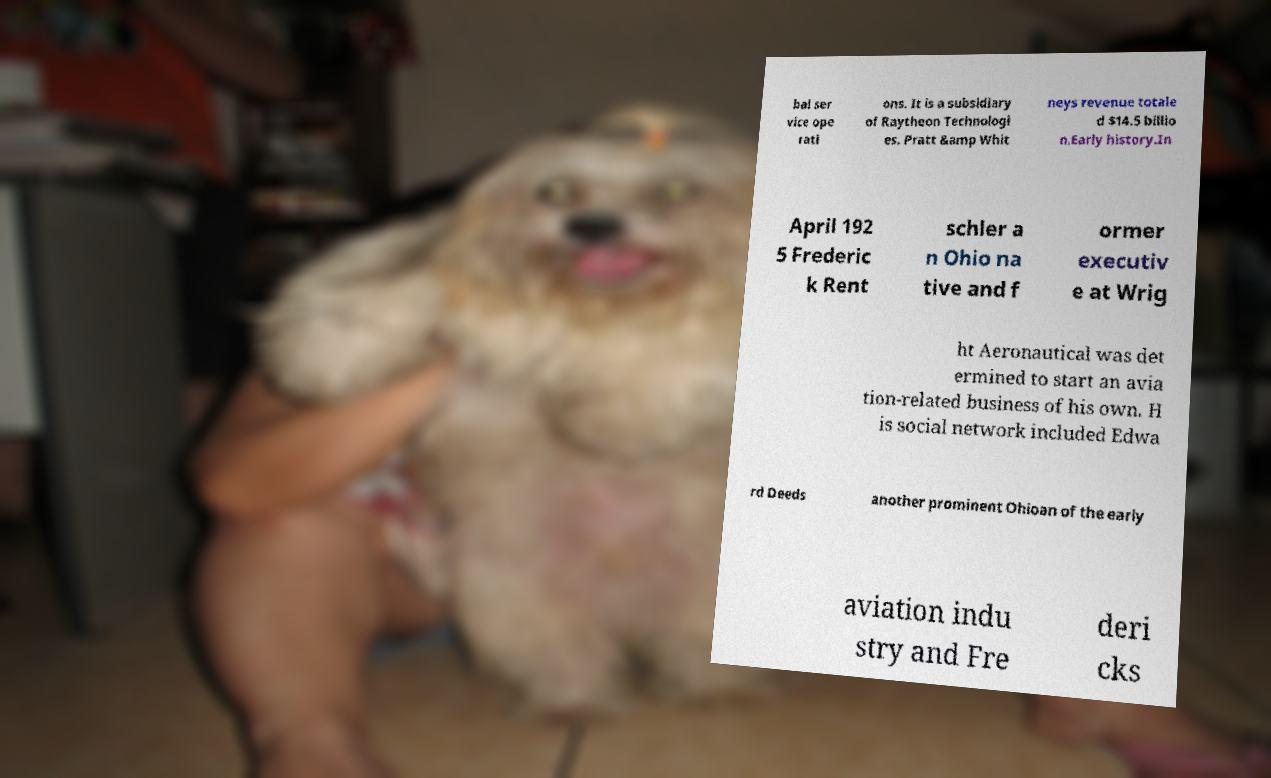For documentation purposes, I need the text within this image transcribed. Could you provide that? bal ser vice ope rati ons. It is a subsidiary of Raytheon Technologi es. Pratt &amp Whit neys revenue totale d $14.5 billio n.Early history.In April 192 5 Frederic k Rent schler a n Ohio na tive and f ormer executiv e at Wrig ht Aeronautical was det ermined to start an avia tion-related business of his own. H is social network included Edwa rd Deeds another prominent Ohioan of the early aviation indu stry and Fre deri cks 